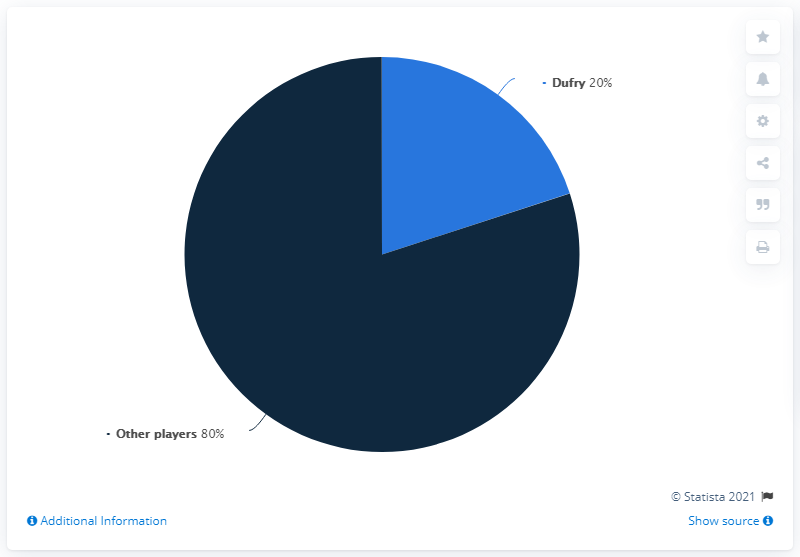Outline some significant characteristics in this image. The angle covered by the small segment is 72 degrees. In 2017, Dufry accounted for approximately X% of the global airport retail market. The result of subtracting Dufry's market share from the average market share is 30. 